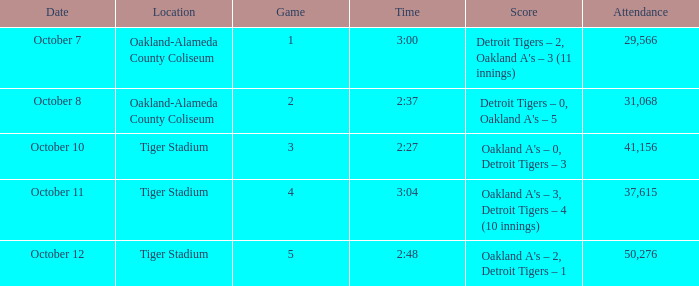What is the number of people in attendance at Oakland-Alameda County Coliseum, and game is 2? 31068.0. 